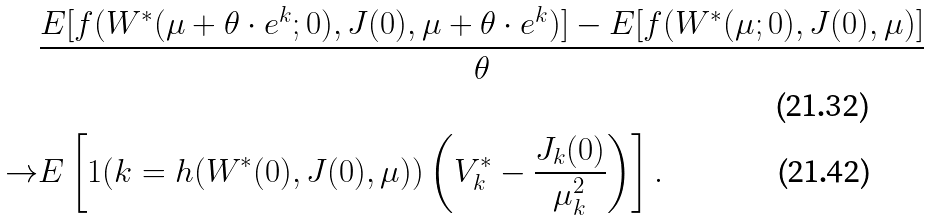<formula> <loc_0><loc_0><loc_500><loc_500>& \frac { E [ f ( W ^ { * } ( \mu + \theta \cdot e ^ { k } ; 0 ) , J ( 0 ) , \mu + \theta \cdot e ^ { k } ) ] - E [ f ( W ^ { * } ( \mu ; 0 ) , J ( 0 ) , \mu ) ] } { \theta } \\ \rightarrow & E \left [ 1 ( k = h ( W ^ { * } ( 0 ) , J ( 0 ) , \mu ) ) \left ( V ^ { * } _ { k } - \frac { J _ { k } ( 0 ) } { \mu _ { k } ^ { 2 } } \right ) \right ] .</formula> 